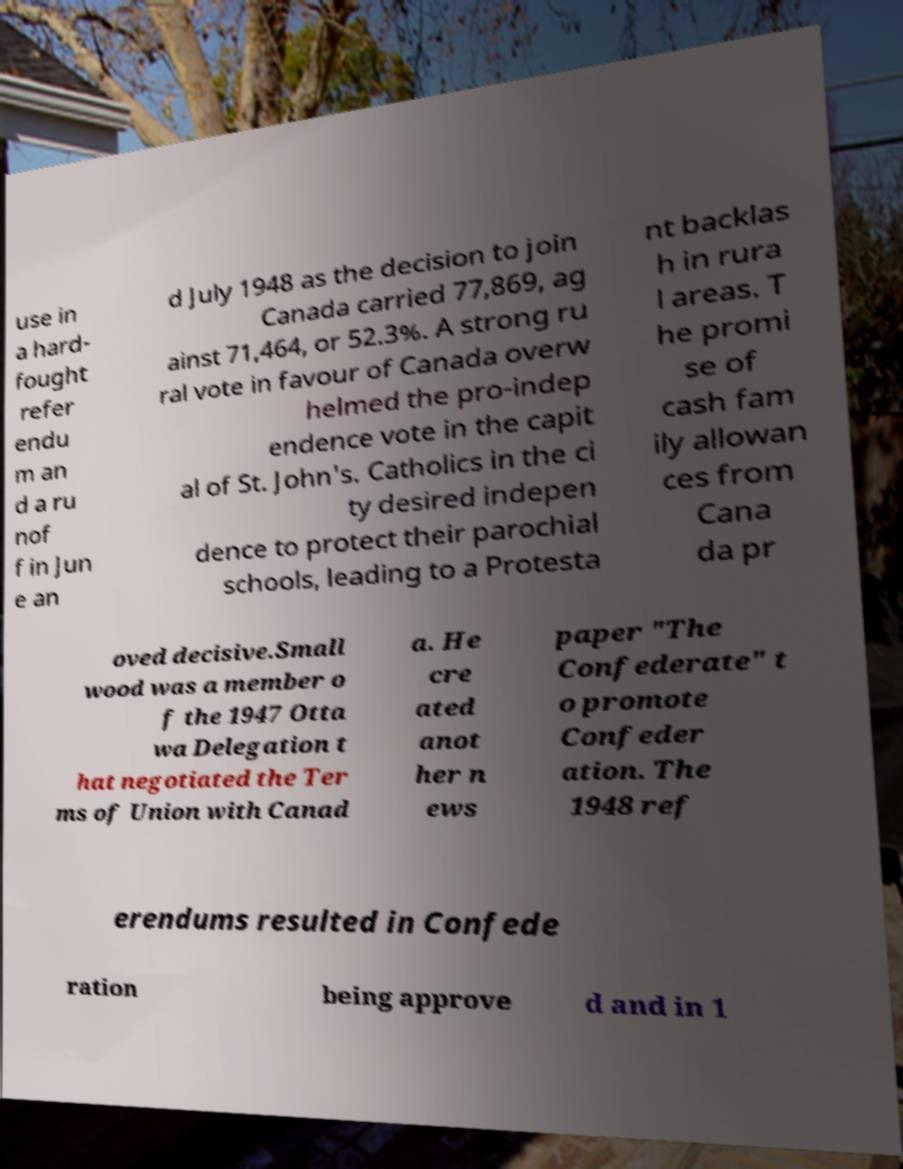Can you accurately transcribe the text from the provided image for me? use in a hard- fought refer endu m an d a ru nof f in Jun e an d July 1948 as the decision to join Canada carried 77,869, ag ainst 71,464, or 52.3%. A strong ru ral vote in favour of Canada overw helmed the pro-indep endence vote in the capit al of St. John's. Catholics in the ci ty desired indepen dence to protect their parochial schools, leading to a Protesta nt backlas h in rura l areas. T he promi se of cash fam ily allowan ces from Cana da pr oved decisive.Small wood was a member o f the 1947 Otta wa Delegation t hat negotiated the Ter ms of Union with Canad a. He cre ated anot her n ews paper "The Confederate" t o promote Confeder ation. The 1948 ref erendums resulted in Confede ration being approve d and in 1 